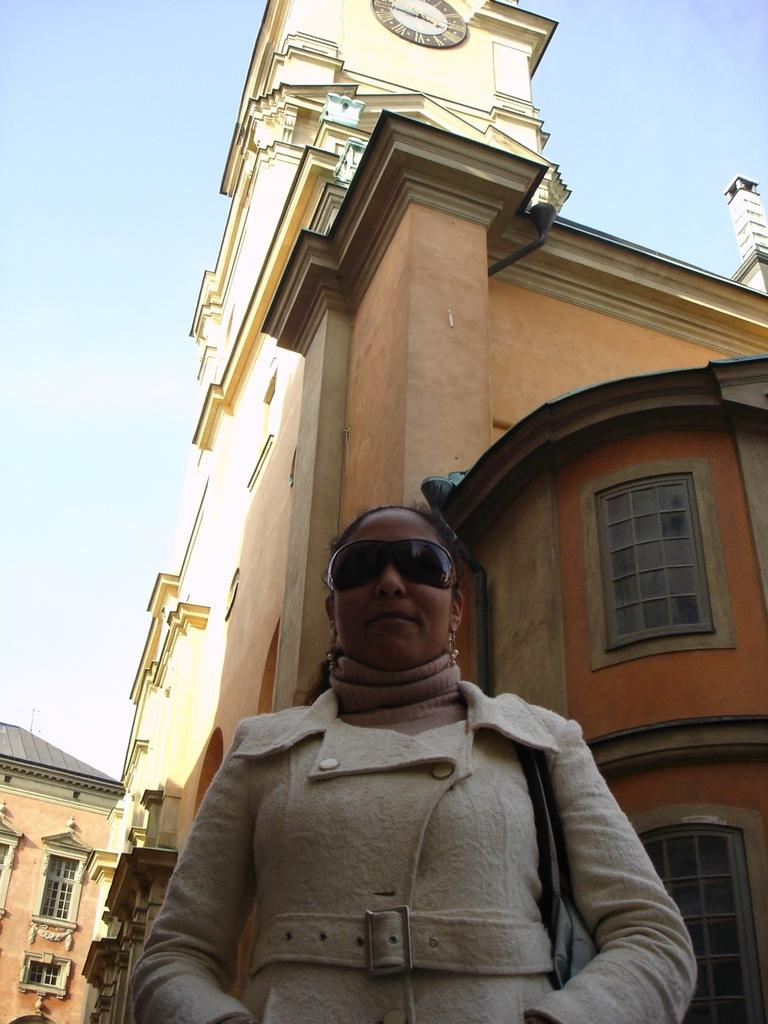Who is the main subject in the image? There is a lady in the center of the image. What is the lady wearing on her face? The lady is wearing goggles. What is the lady's posture? The lady is standing. What can be seen behind the lady? There is a building behind the lady. What is visible in the background of the image? The sky is visible in the background of the image. What type of jeans is the lady wearing in the image? The provided facts do not mention any jeans being worn by the lady in the image. 